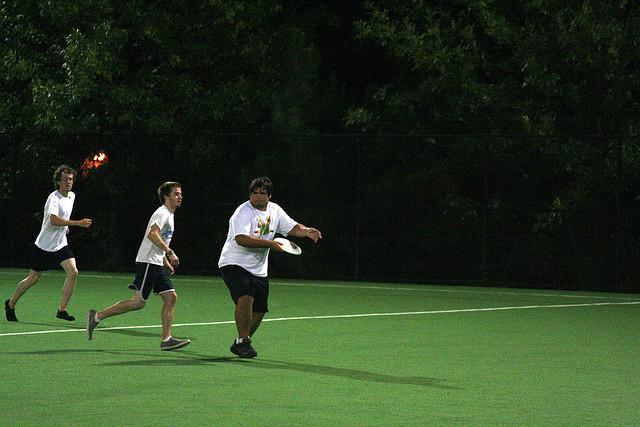How many people on the field?
Give a very brief answer. 3. How many people can be seen?
Give a very brief answer. 3. 